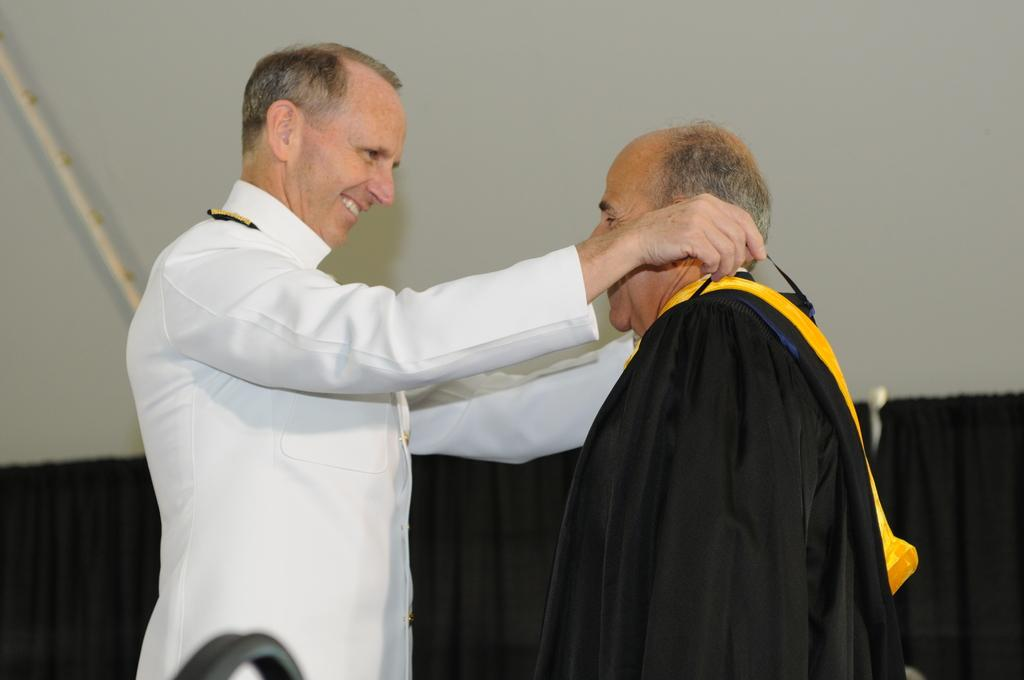How many people are in the image? There are two men standing in the image. What is the facial expression of the men? The men are smiling. What type of window treatment is present in the image? There are curtains hanging from a hanger. What type of structure is visible in the image? There is a wall visible in the image. Reasoning: Let' Let's think step by step in order to produce the conversation. We start by identifying the main subjects in the image, which are the two men. Then, we describe their facial expressions to provide more context about their mood or demeanor. Next, we focus on the window treatment, which is the curtains hanging from a hanger. Finally, we mention the wall as a structural element visible in the image. Absurd Question/Answer: What type of pollution can be seen in the image? There is no pollution visible in the image. Is there a scarecrow playing a guitar in the image? No, there is no scarecrow or guitar present in the image. 